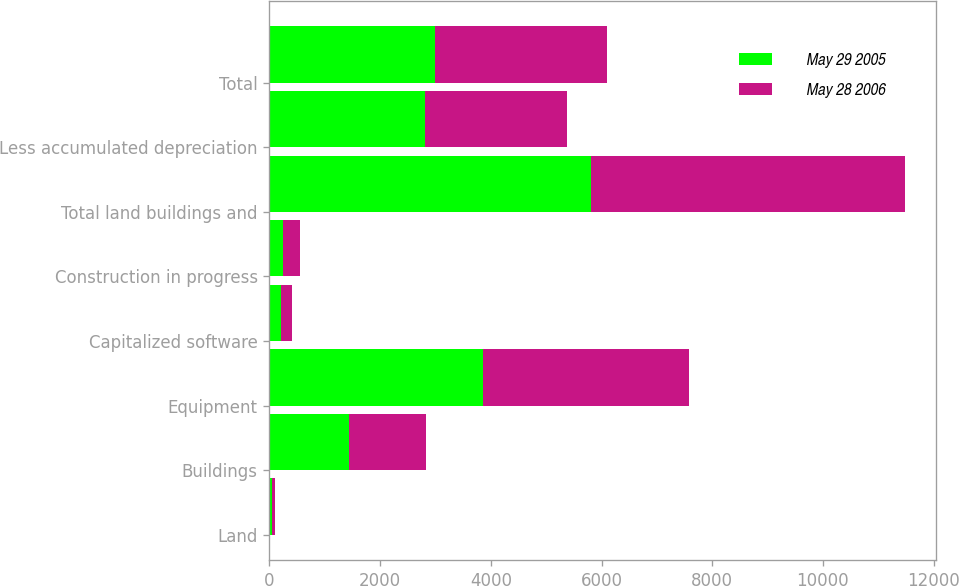<chart> <loc_0><loc_0><loc_500><loc_500><stacked_bar_chart><ecel><fcel>Land<fcel>Buildings<fcel>Equipment<fcel>Capitalized software<fcel>Construction in progress<fcel>Total land buildings and<fcel>Less accumulated depreciation<fcel>Total<nl><fcel>May 29 2005<fcel>54<fcel>1430<fcel>3859<fcel>211<fcel>252<fcel>5806<fcel>2809<fcel>2997<nl><fcel>May 28 2006<fcel>54<fcel>1396<fcel>3722<fcel>196<fcel>302<fcel>5670<fcel>2559<fcel>3111<nl></chart> 